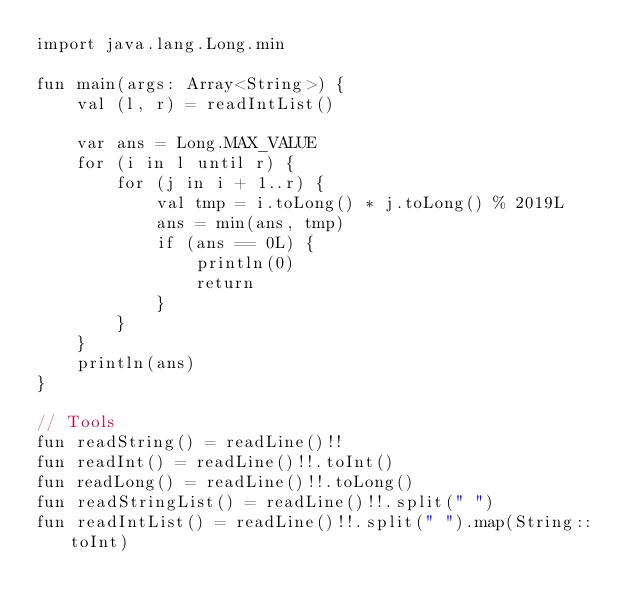Convert code to text. <code><loc_0><loc_0><loc_500><loc_500><_Kotlin_>import java.lang.Long.min

fun main(args: Array<String>) {
    val (l, r) = readIntList()

    var ans = Long.MAX_VALUE
    for (i in l until r) {
        for (j in i + 1..r) {
            val tmp = i.toLong() * j.toLong() % 2019L
            ans = min(ans, tmp)
            if (ans == 0L) {
                println(0)
                return
            }
        }
    }
    println(ans)
}

// Tools
fun readString() = readLine()!!
fun readInt() = readLine()!!.toInt()
fun readLong() = readLine()!!.toLong()
fun readStringList() = readLine()!!.split(" ")
fun readIntList() = readLine()!!.split(" ").map(String::toInt)</code> 